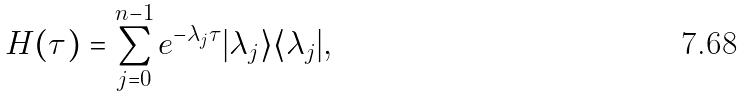<formula> <loc_0><loc_0><loc_500><loc_500>H ( \tau ) = \sum _ { j = 0 } ^ { n - 1 } e ^ { - \lambda _ { j } \tau } | \lambda _ { j } \rangle \langle \lambda _ { j } | ,</formula> 